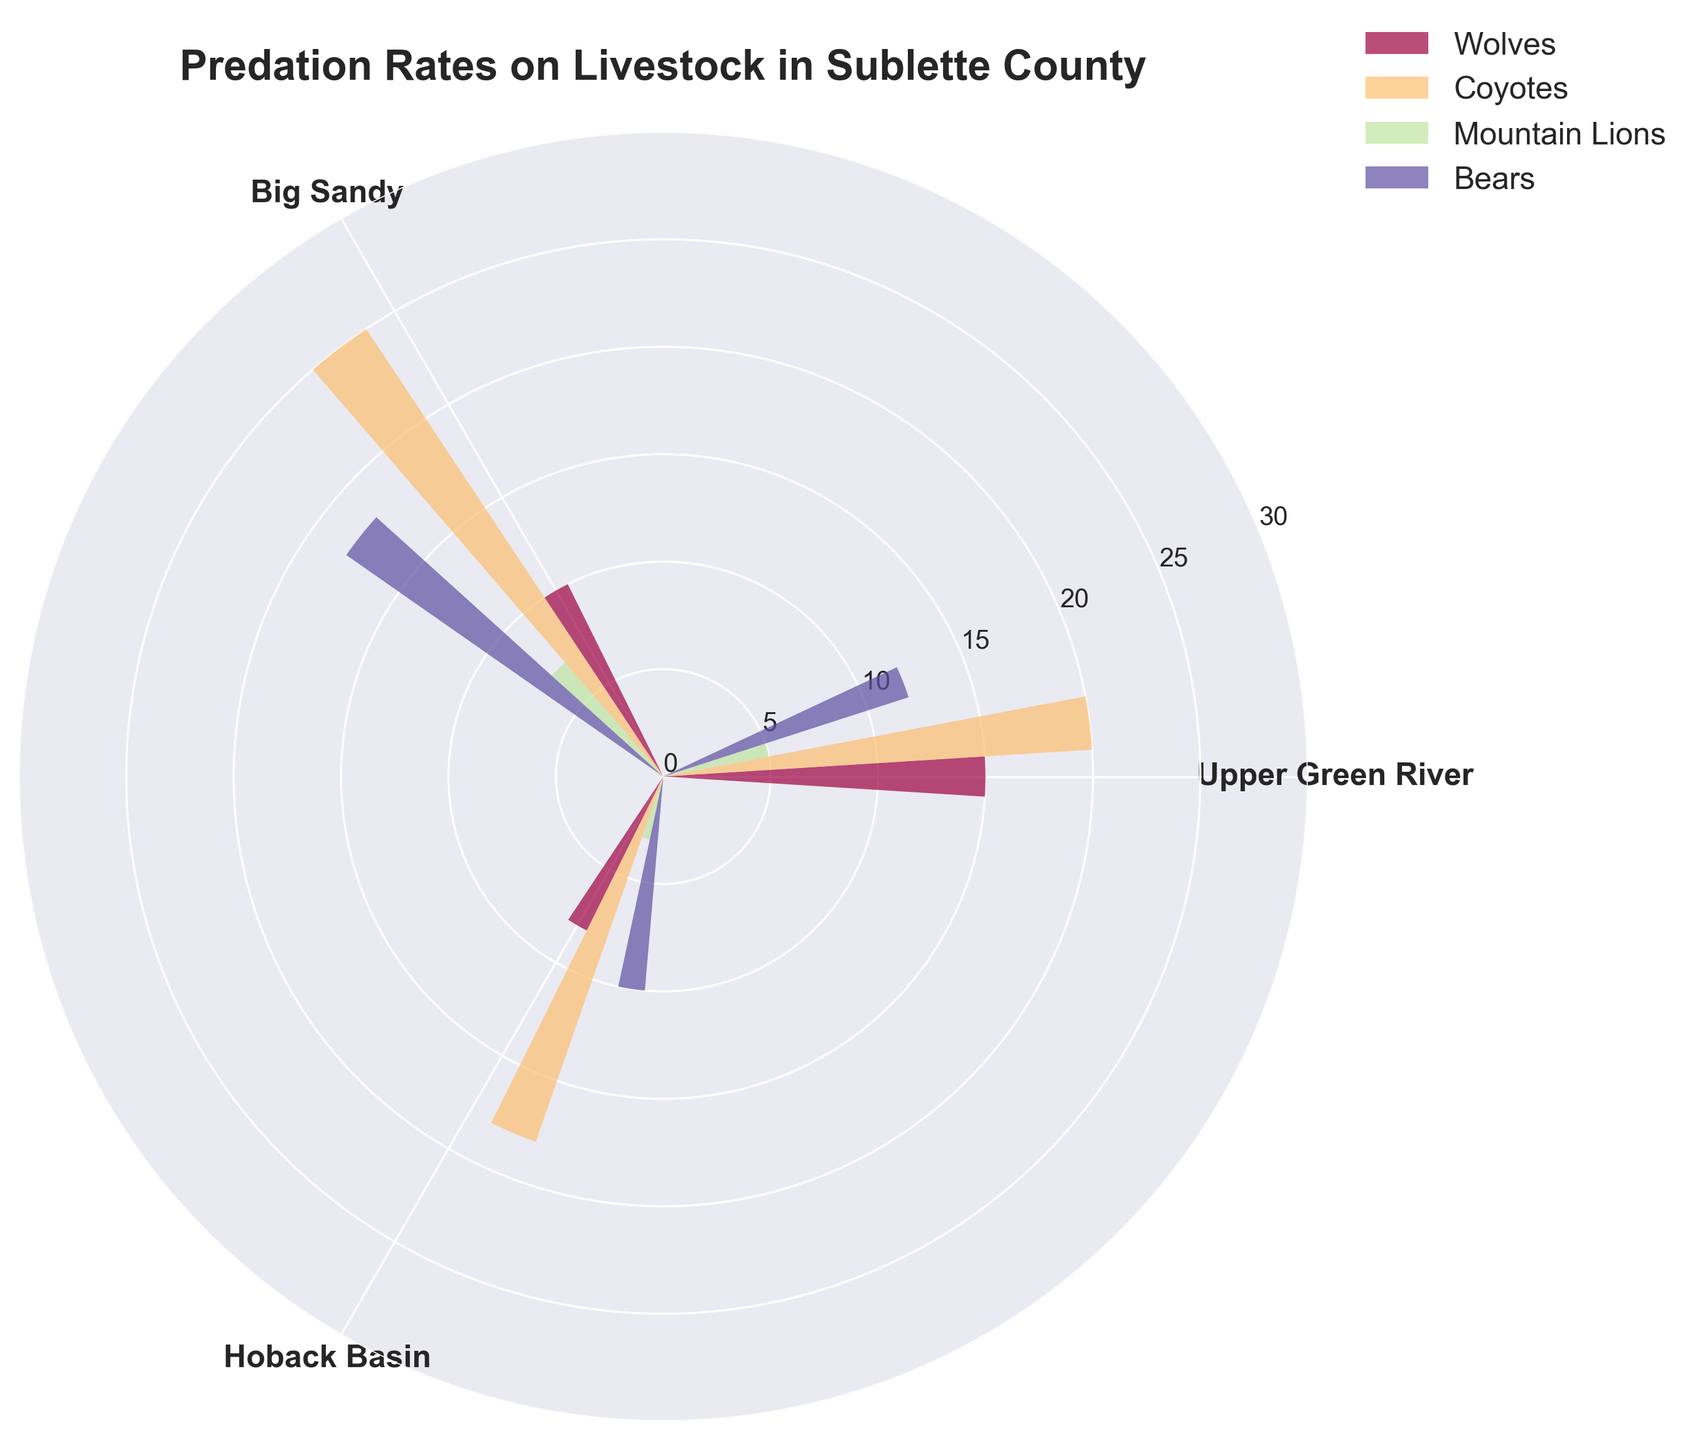What is the title of the chart? The title is displayed prominently on the upper part of the chart. It provides a summary of what the chart represents.
Answer: Predation Rates on Livestock in Sublette County Which predator has the highest predation rate in the Upper Green River region? By observing the sections corresponding to the Upper Green River region, we can compare the heights of different predator bars. The tallest bar will indicate the highest predation rate.
Answer: Coyotes How many regions are represented in the chart? The chart is divided equally into sections, each representing a region. Counting these sections will give the total number of regions.
Answer: 3 What is the difference in predation rates between Bears and Mountain Lions in the Big Sandy region? Locate the bars representing Bears and Mountain Lions in the Big Sandy section, then subtract the Mountain Lions' predation rate from Bears'.
Answer: 11 Which predator has the lowest overall predation rate across all regions? By comparing the heights of all bars for each predator across all regions, the one with the shortest bars on average indicates the lowest overall predation rate.
Answer: Mountain Lions What is the average predation rate for Coyotes across all regions? Add the predation rates for Coyotes in all regions and divide by the number of regions. For Coyotes: (20 + 25 + 18) / 3.
Answer: 21 In which region do Wolves have the least predation rate? Compare the heights of the bars representing Wolves in each section of the chart. The shortest bar shows the region with the least predation rate.
Answer: Hoback Basin Which region has the highest predation rate from all predators combined? Sum the predation rates for all predators in each region and compare the totals.
Answer: Big Sandy How does the predation rate of Bears in Hoback Basin compare to that in Big Sandy? Compare the heights of the bars for Bears in both the Hoback Basin and Big Sandy sections.
Answer: Less Which other predator has a similar predation rate to Wolves in the Upper Green River region? Look for a bar in the Upper Green River region that is approximately the same height as the Wolves' bar.
Answer: Bears How do the predation rates of Coyotes in Big Sandy and Hoback Basin compare? Observe the heights of the bars representing Coyotes in the Big Sandy and Hoback Basin sections and compare them.
Answer: Coyotes in Big Sandy have a higher predation rate than in Hoback Basin 